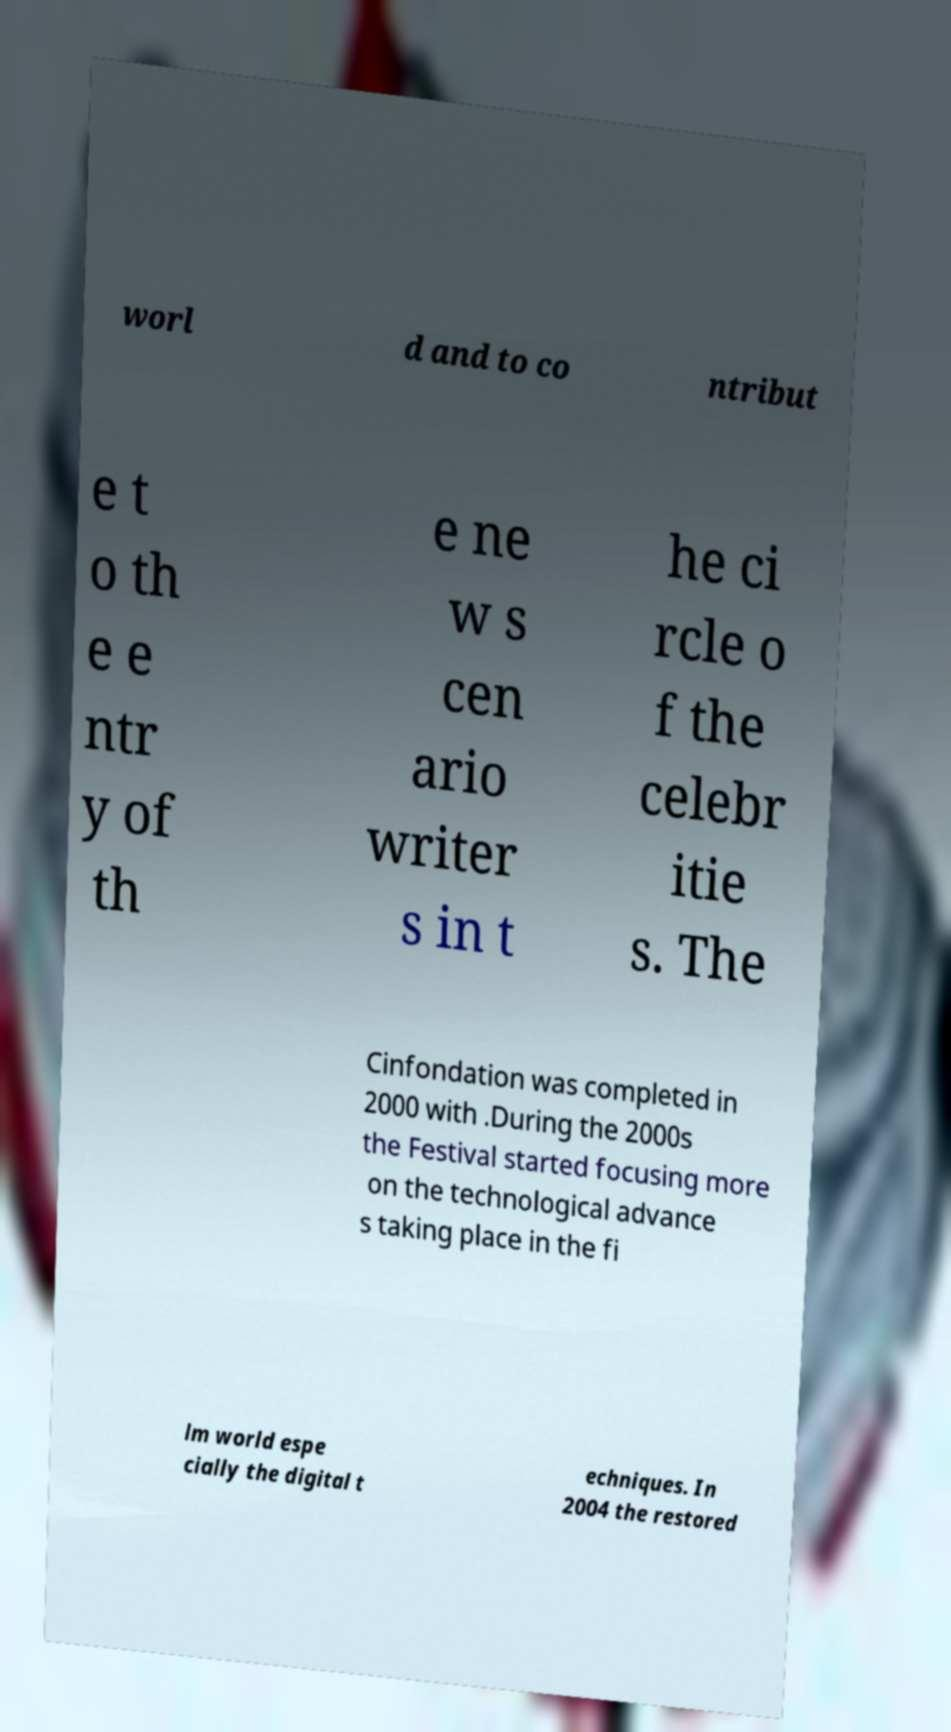What messages or text are displayed in this image? I need them in a readable, typed format. worl d and to co ntribut e t o th e e ntr y of th e ne w s cen ario writer s in t he ci rcle o f the celebr itie s. The Cinfondation was completed in 2000 with .During the 2000s the Festival started focusing more on the technological advance s taking place in the fi lm world espe cially the digital t echniques. In 2004 the restored 